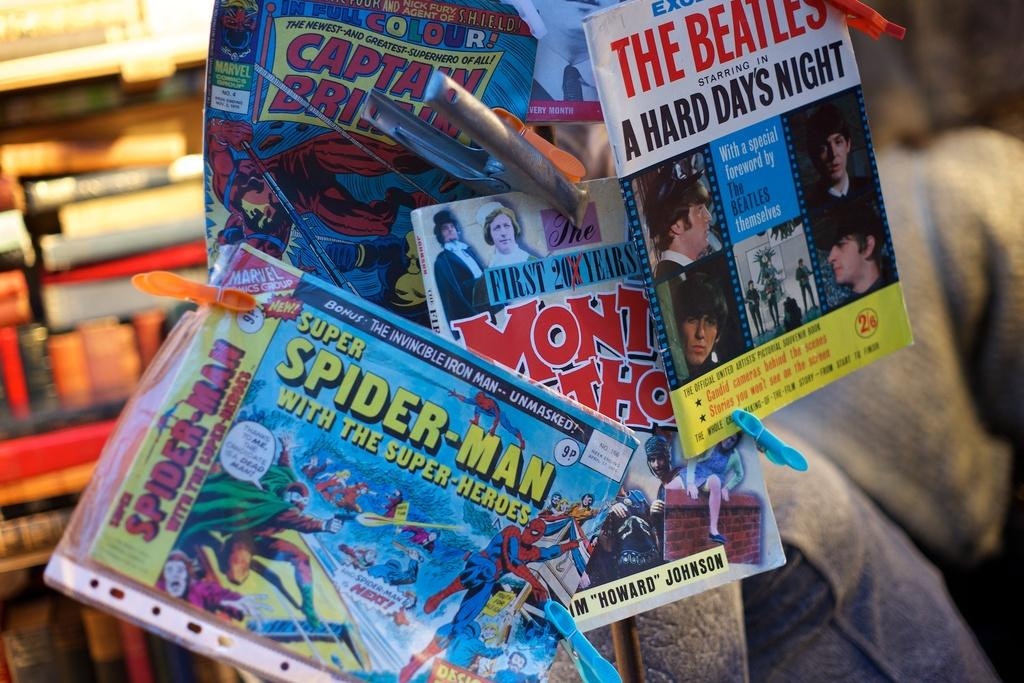<image>
Summarize the visual content of the image. A stack of Spider-man comics that are clipped to other books like Monty Python. 